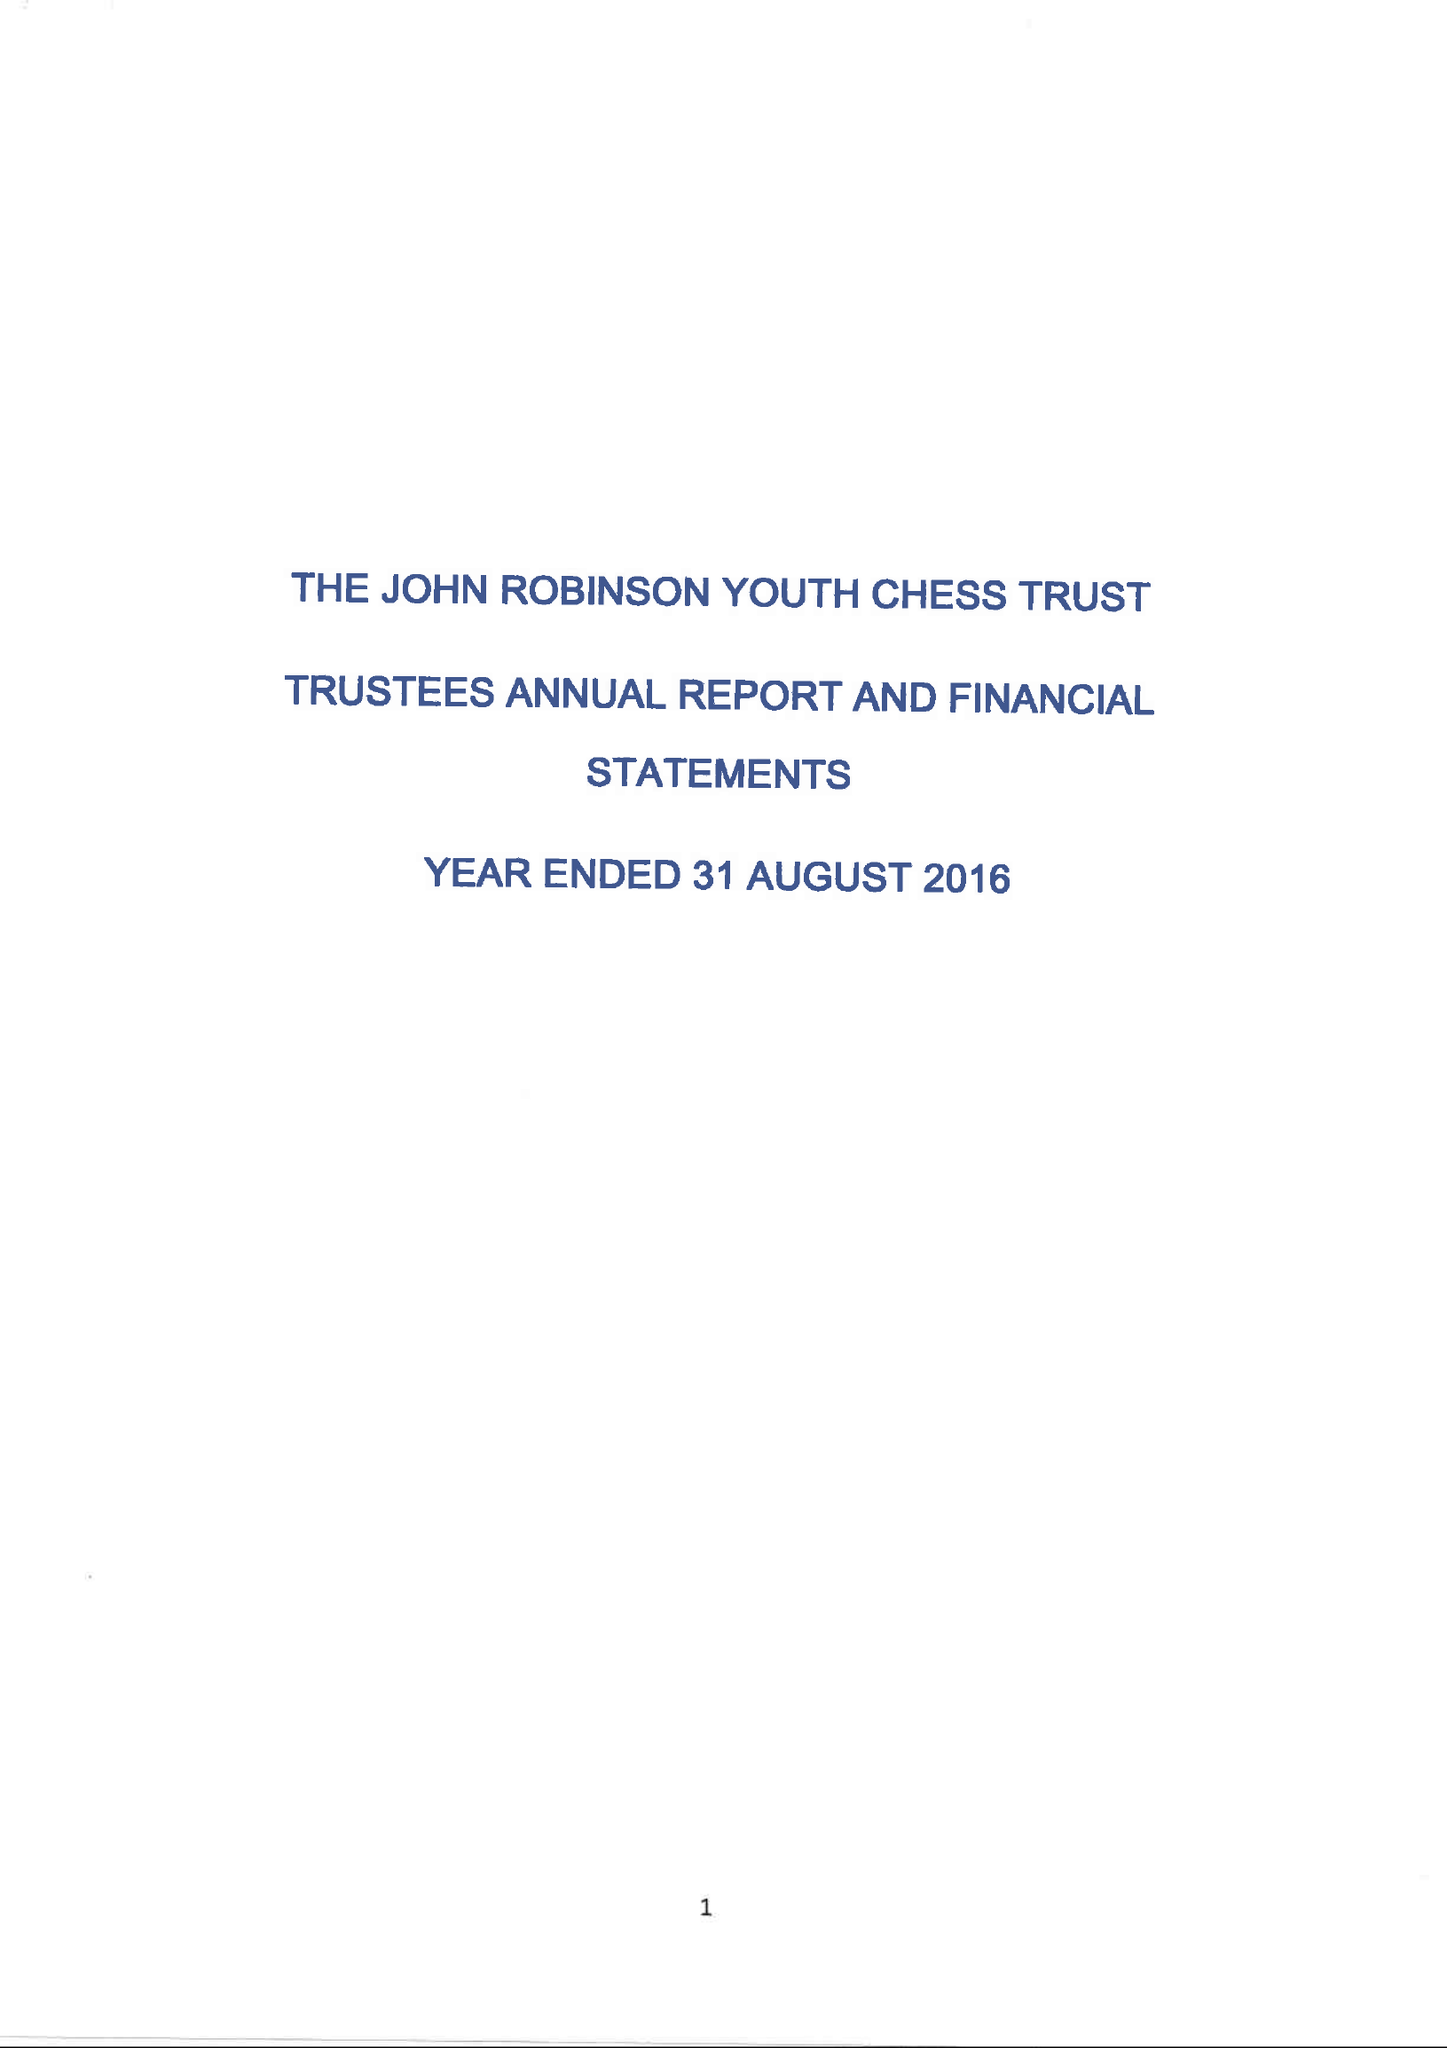What is the value for the spending_annually_in_british_pounds?
Answer the question using a single word or phrase. 26642.00 